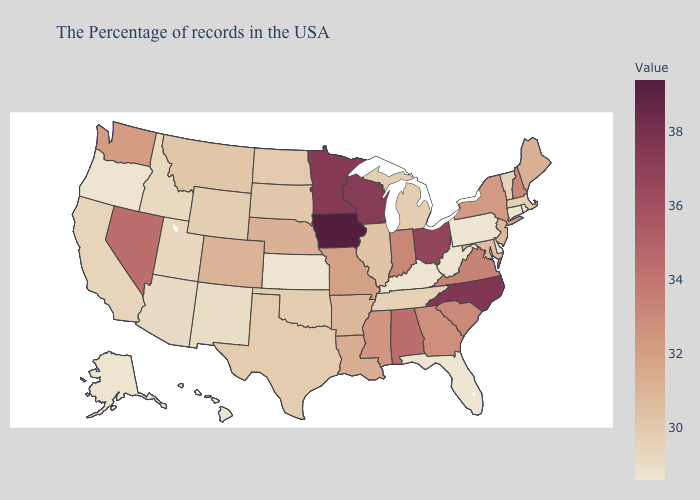Does Maine have the lowest value in the Northeast?
Concise answer only. No. Does the map have missing data?
Answer briefly. No. Does North Carolina have a higher value than Iowa?
Quick response, please. No. Among the states that border Wisconsin , which have the highest value?
Quick response, please. Iowa. Does Minnesota have the highest value in the USA?
Answer briefly. No. 